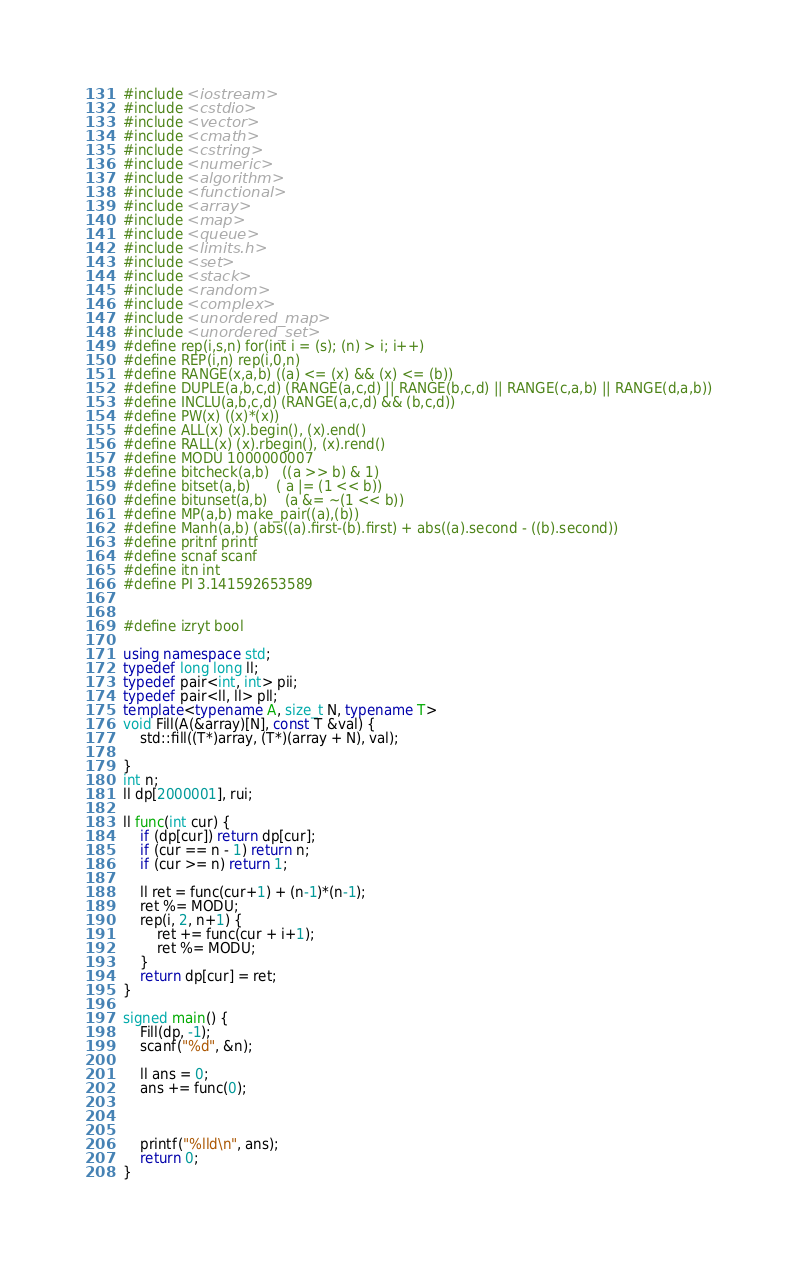Convert code to text. <code><loc_0><loc_0><loc_500><loc_500><_C++_>#include <iostream>
#include <cstdio>
#include <vector>
#include <cmath>
#include <cstring>
#include <numeric>
#include <algorithm>
#include <functional>
#include <array>
#include <map>
#include <queue>
#include <limits.h>
#include <set>
#include <stack>
#include <random>
#include <complex>
#include <unordered_map>
#include <unordered_set>
#define rep(i,s,n) for(int i = (s); (n) > i; i++)
#define REP(i,n) rep(i,0,n)
#define RANGE(x,a,b) ((a) <= (x) && (x) <= (b))
#define DUPLE(a,b,c,d) (RANGE(a,c,d) || RANGE(b,c,d) || RANGE(c,a,b) || RANGE(d,a,b))
#define INCLU(a,b,c,d) (RANGE(a,c,d) && (b,c,d))
#define PW(x) ((x)*(x))
#define ALL(x) (x).begin(), (x).end()
#define RALL(x) (x).rbegin(), (x).rend()
#define MODU 1000000007
#define bitcheck(a,b)   ((a >> b) & 1)
#define bitset(a,b)      ( a |= (1 << b))
#define bitunset(a,b)    (a &= ~(1 << b))
#define MP(a,b) make_pair((a),(b))
#define Manh(a,b) (abs((a).first-(b).first) + abs((a).second - ((b).second))
#define pritnf printf
#define scnaf scanf
#define itn int
#define PI 3.141592653589


#define izryt bool

using namespace std;
typedef long long ll;
typedef pair<int, int> pii;
typedef pair<ll, ll> pll;
template<typename A, size_t N, typename T>
void Fill(A(&array)[N], const T &val) {
	std::fill((T*)array, (T*)(array + N), val);

}
int n;
ll dp[2000001], rui;

ll func(int cur) {
	if (dp[cur]) return dp[cur];
	if (cur == n - 1) return n;
	if (cur >= n) return 1;

	ll ret = func(cur+1) + (n-1)*(n-1);
	ret %= MODU;
	rep(i, 2, n+1) {
		ret += func(cur + i+1);
		ret %= MODU;
	}
	return dp[cur] = ret;
}

signed main() {
	Fill(dp, -1);
	scanf("%d", &n);

	ll ans = 0;
	ans += func(0);



	printf("%lld\n", ans);
	return 0;
}</code> 